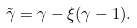Convert formula to latex. <formula><loc_0><loc_0><loc_500><loc_500>\tilde { \gamma } = \gamma - \xi ( \gamma - 1 ) .</formula> 